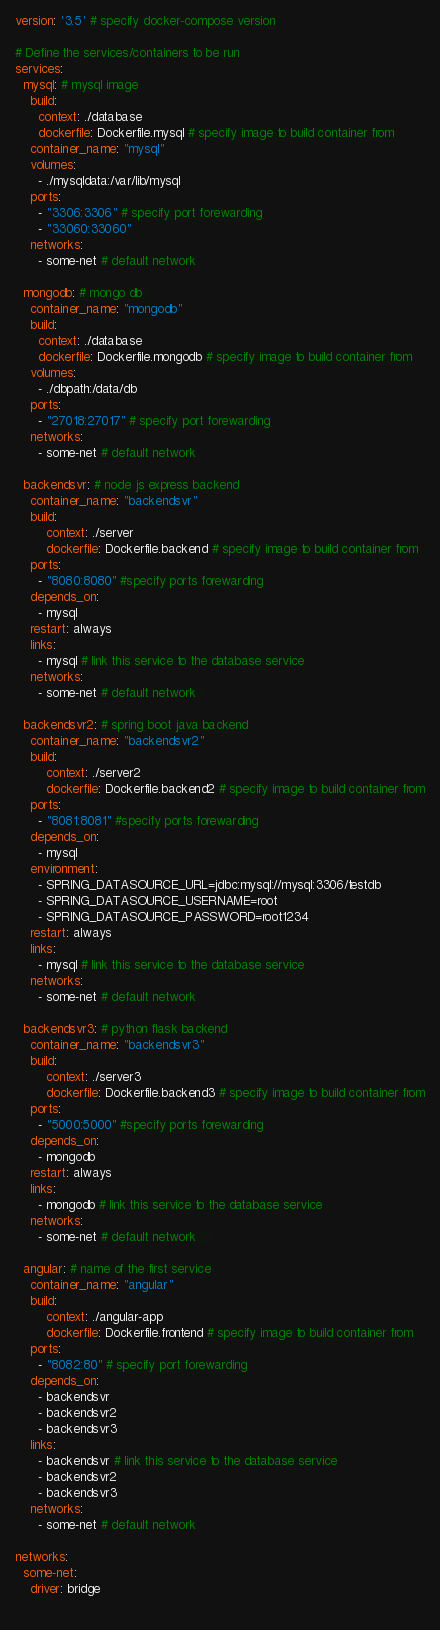Convert code to text. <code><loc_0><loc_0><loc_500><loc_500><_YAML_>version: '3.5' # specify docker-compose version

# Define the services/containers to be run
services:
  mysql: # mysql image
    build: 
      context: ./database
      dockerfile: Dockerfile.mysql # specify image to build container from
    container_name: "mysql"
    volumes:
      - ./mysqldata:/var/lib/mysql
    ports:
      - "3306:3306" # specify port forewarding
      - "33060:33060"
    networks:
      - some-net # default network

  mongodb: # mongo db 
    container_name: "mongodb"   
    build: 
      context: ./database
      dockerfile: Dockerfile.mongodb # specify image to build container from
    volumes:
      - ./dbpath:/data/db 
    ports:
      - "27018:27017" # specify port forewarding
    networks:
      - some-net # default network

  backendsvr: # node js express backend
    container_name: "backendsvr"
    build: 
        context: ./server
        dockerfile: Dockerfile.backend # specify image to build container from
    ports:
      - "8080:8080" #specify ports forewarding
    depends_on:
      - mysql
    restart: always
    links:
      - mysql # link this service to the database service
    networks:
      - some-net # default network  

  backendsvr2: # spring boot java backend
    container_name: "backendsvr2"
    build: 
        context: ./server2
        dockerfile: Dockerfile.backend2 # specify image to build container from
    ports:
      - "8081:8081" #specify ports forewarding
    depends_on:
      - mysql
    environment:
      - SPRING_DATASOURCE_URL=jdbc:mysql://mysql:3306/testdb
      - SPRING_DATASOURCE_USERNAME=root
      - SPRING_DATASOURCE_PASSWORD=root1234  
    restart: always
    links:
      - mysql # link this service to the database service
    networks:
      - some-net # default network
  
  backendsvr3: # python flask backend
    container_name: "backendsvr3"
    build: 
        context: ./server3
        dockerfile: Dockerfile.backend3 # specify image to build container from
    ports:
      - "5000:5000" #specify ports forewarding
    depends_on:
      - mongodb
    restart: always
    links:
      - mongodb # link this service to the database service
    networks:
      - some-net # default network    
  
  angular: # name of the first service
    container_name: "angular"
    build: 
        context: ./angular-app
        dockerfile: Dockerfile.frontend # specify image to build container from
    ports:
      - "8082:80" # specify port forewarding
    depends_on:
      - backendsvr
      - backendsvr2
      - backendsvr3  
    links:
      - backendsvr # link this service to the database service
      - backendsvr2
      - backendsvr3
    networks:
      - some-net # default network

networks:
  some-net:
    driver: bridge
    
</code> 